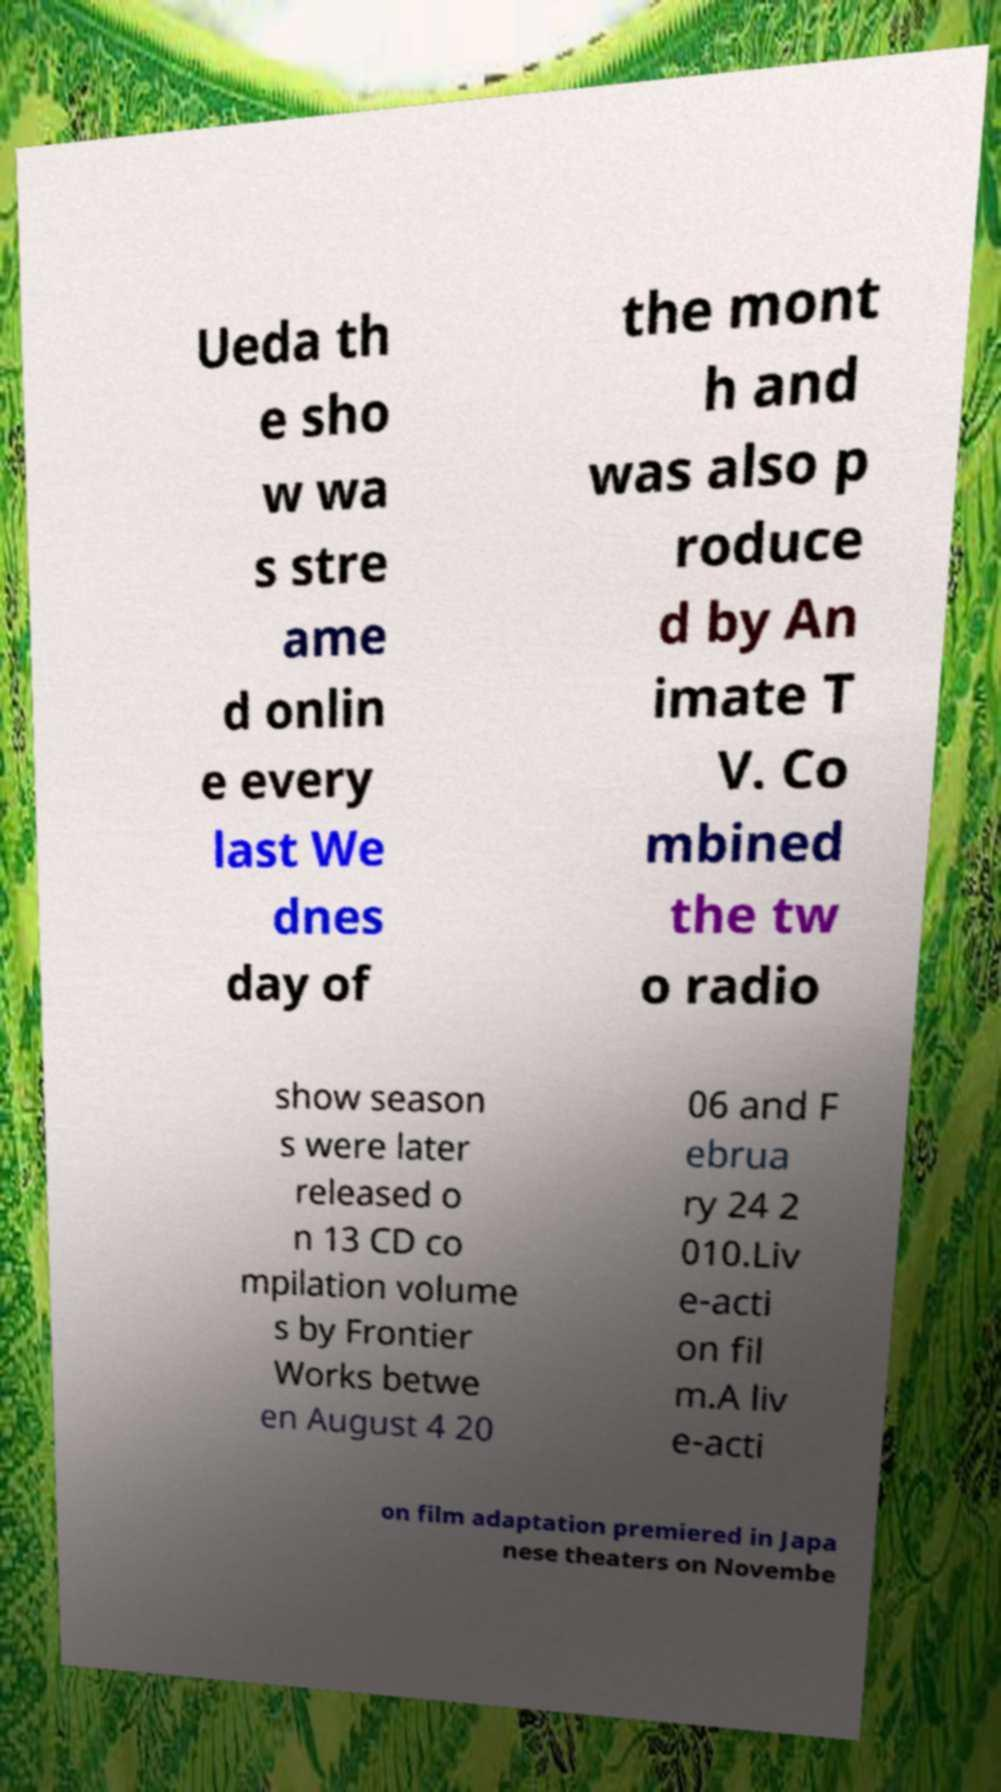For documentation purposes, I need the text within this image transcribed. Could you provide that? Ueda th e sho w wa s stre ame d onlin e every last We dnes day of the mont h and was also p roduce d by An imate T V. Co mbined the tw o radio show season s were later released o n 13 CD co mpilation volume s by Frontier Works betwe en August 4 20 06 and F ebrua ry 24 2 010.Liv e-acti on fil m.A liv e-acti on film adaptation premiered in Japa nese theaters on Novembe 